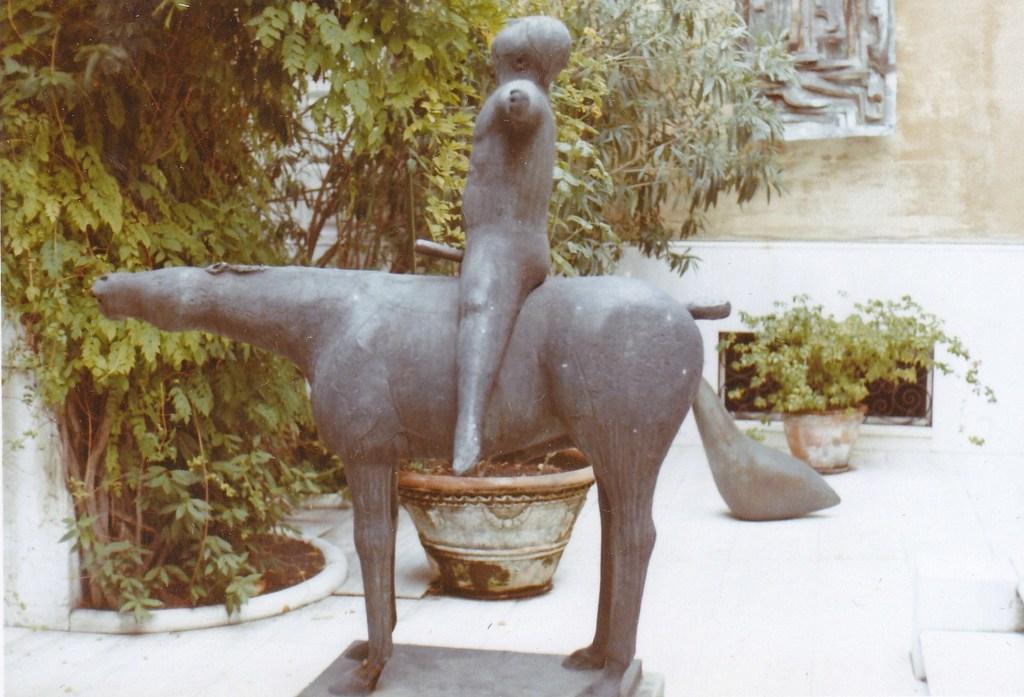Describe this image in one or two sentences. In this image we can see there are a depiction of a person sitting on the animal, in the background there are trees, plant pots and there is a structure on the wall. 